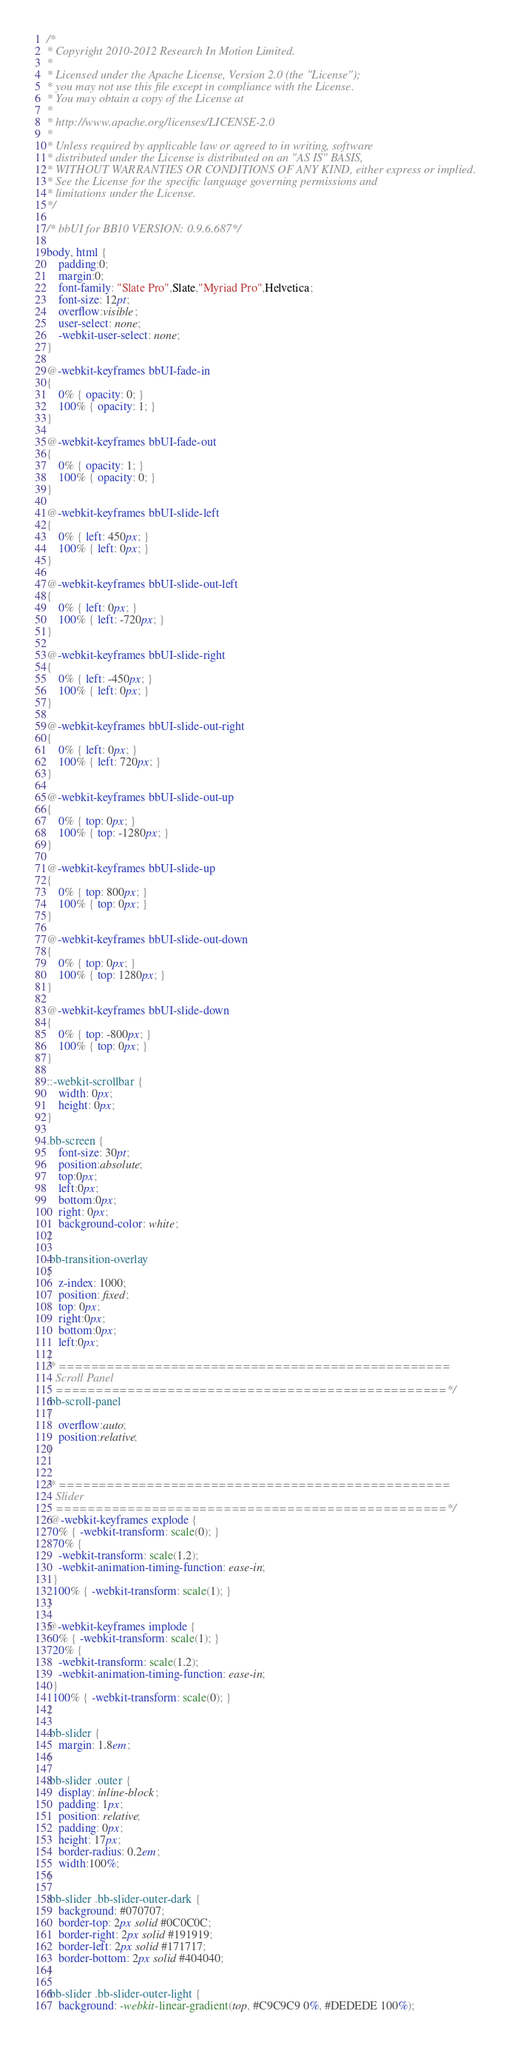Convert code to text. <code><loc_0><loc_0><loc_500><loc_500><_CSS_>/*
* Copyright 2010-2012 Research In Motion Limited.
*
* Licensed under the Apache License, Version 2.0 (the "License");
* you may not use this file except in compliance with the License.
* You may obtain a copy of the License at
*
* http://www.apache.org/licenses/LICENSE-2.0
*
* Unless required by applicable law or agreed to in writing, software
* distributed under the License is distributed on an "AS IS" BASIS,
* WITHOUT WARRANTIES OR CONDITIONS OF ANY KIND, either express or implied.
* See the License for the specific language governing permissions and
* limitations under the License.
*/

/* bbUI for BB10 VERSION: 0.9.6.687*/

body, html {
	padding:0;
	margin:0;
	font-family: "Slate Pro",Slate,"Myriad Pro",Helvetica;
	font-size: 12pt;
	overflow:visible;
	user-select: none;
	-webkit-user-select: none;
}

@-webkit-keyframes bbUI-fade-in 
{ 
	0% { opacity: 0; } 
	100% { opacity: 1; } 
}

@-webkit-keyframes bbUI-fade-out 
{ 
	0% { opacity: 1; } 
	100% { opacity: 0; } 
}

@-webkit-keyframes bbUI-slide-left 
{ 
	0% { left: 450px; } 
	100% { left: 0px; } 
}

@-webkit-keyframes bbUI-slide-out-left 
{ 
	0% { left: 0px; } 
	100% { left: -720px; } 
}

@-webkit-keyframes bbUI-slide-right 
{ 
	0% { left: -450px; } 
	100% { left: 0px; } 
}

@-webkit-keyframes bbUI-slide-out-right 
{ 
	0% { left: 0px; } 
	100% { left: 720px; } 
}

@-webkit-keyframes bbUI-slide-out-up 
{ 
	0% { top: 0px; } 
	100% { top: -1280px; } 
}

@-webkit-keyframes bbUI-slide-up 
{ 
	0% { top: 800px; } 
	100% { top: 0px; } 
}

@-webkit-keyframes bbUI-slide-out-down 
{ 
	0% { top: 0px; } 
	100% { top: 1280px; } 
}

@-webkit-keyframes bbUI-slide-down 
{ 
	0% { top: -800px; } 
	100% { top: 0px; } 
}

::-webkit-scrollbar {
    width: 0px;
    height: 0px;
}

.bb-screen {
	font-size: 30pt;
	position:absolute;
	top:0px;
	left:0px;
	bottom:0px;
	right: 0px;
	background-color: white;
}

.bb-transition-overlay
{
	z-index: 1000;
	position: fixed;
	top: 0px;
	right:0px;
	bottom:0px;
	left:0px;
}
/* ================================================= 
   Scroll Panel
   =================================================*/
.bb-scroll-panel
{
	overflow:auto;
	position:relative;
}


/* ================================================= 
   Slider
   =================================================*/
 @-webkit-keyframes explode {  
  0% { -webkit-transform: scale(0); }  
  70% { 
    -webkit-transform: scale(1.2); 
    -webkit-animation-timing-function: ease-in;
  }  
  100% { -webkit-transform: scale(1); }  
}  

@-webkit-keyframes implode {  
  0% { -webkit-transform: scale(1); }  
  20% { 
    -webkit-transform: scale(1.2); 
    -webkit-animation-timing-function: ease-in;
  }  
  100% { -webkit-transform: scale(0); }  
}  

.bb-slider {
	margin: 1.8em;
}

.bb-slider .outer {
    display: inline-block;
    padding: 1px;
	position: relative;
    padding: 0px;
    height: 17px;
	border-radius: 0.2em;
	width:100%;
}

.bb-slider .bb-slider-outer-dark {
	background: #070707;
	border-top: 2px solid #0C0C0C;
    border-right: 2px solid #191919;
    border-left: 2px solid #171717;
    border-bottom: 2px solid #404040; 
}

.bb-slider .bb-slider-outer-light {
	background: -webkit-linear-gradient(top, #C9C9C9 0%, #DEDEDE 100%);</code> 